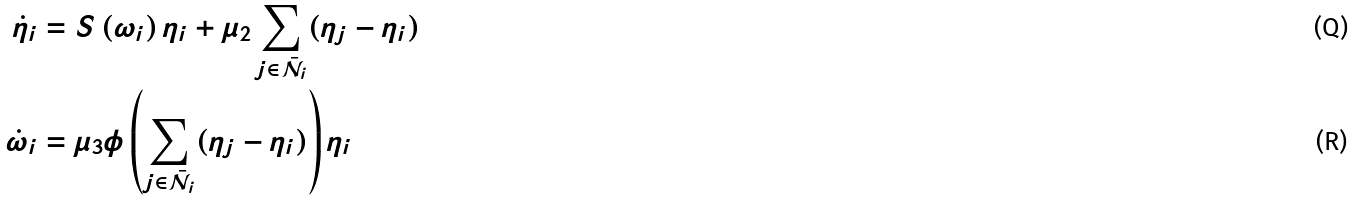<formula> <loc_0><loc_0><loc_500><loc_500>\dot { \eta } _ { i } & = S \left ( \omega _ { i } \right ) \eta _ { i } + \mu _ { 2 } \sum _ { j \in \mathcal { \bar { N } } _ { i } } ( \eta _ { j } - \eta _ { i } ) \\ \dot { \omega } _ { i } & = \mu _ { 3 } \phi \left ( \sum _ { j \in \mathcal { \bar { N } } _ { i } } ( \eta _ { j } - \eta _ { i } ) \right ) \eta _ { i }</formula> 